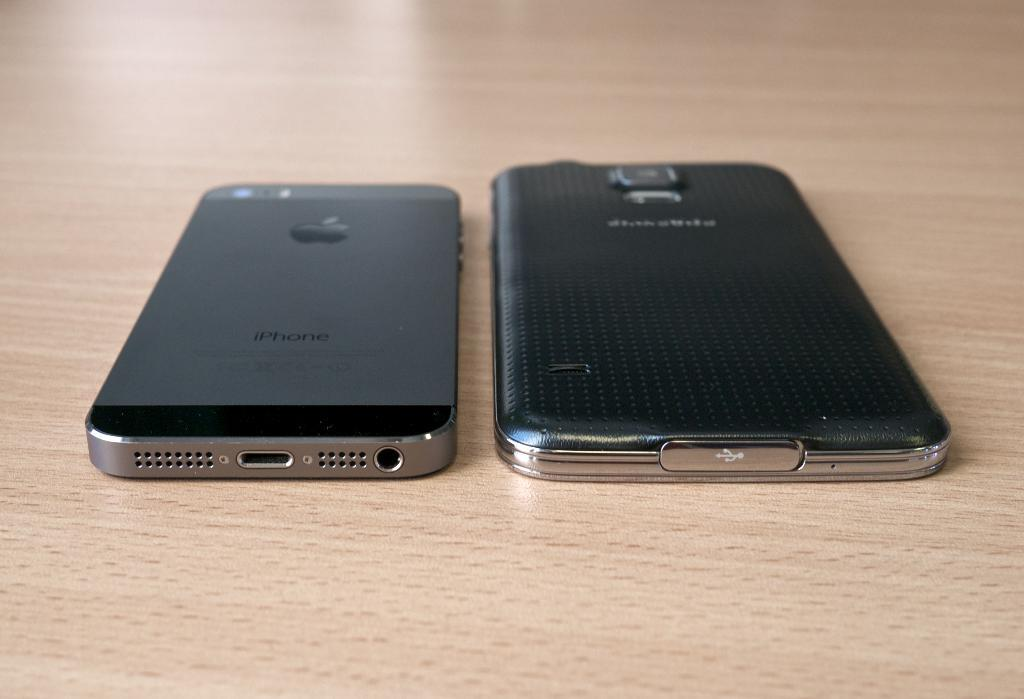<image>
Give a short and clear explanation of the subsequent image. Two phones lay next to each other on a table, and the one on the left is an iPhone. 